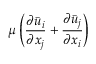<formula> <loc_0><loc_0><loc_500><loc_500>\mu \left ( \frac { { \partial } \ B a r { u } _ { i } } { { \partial } x _ { j } } + \frac { { \partial } \ B a r { u } _ { j } } { { \partial } x _ { i } } \right )</formula> 